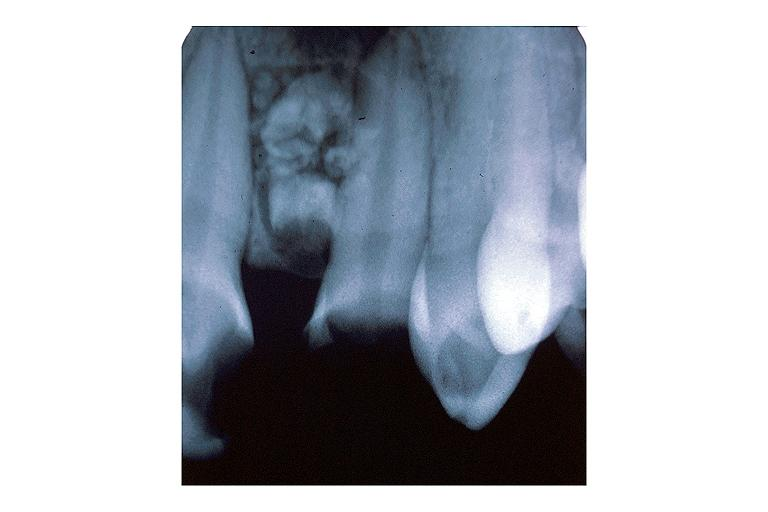does esophagus show compound odontoma?
Answer the question using a single word or phrase. No 